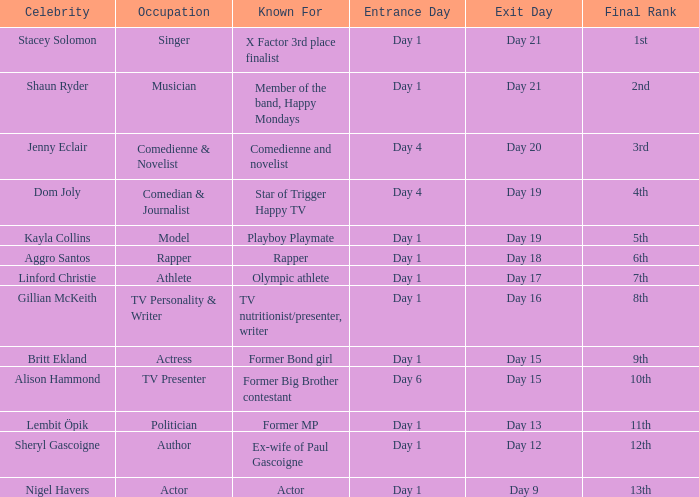Which celebrity was famous for being a rapper? Aggro Santos. 